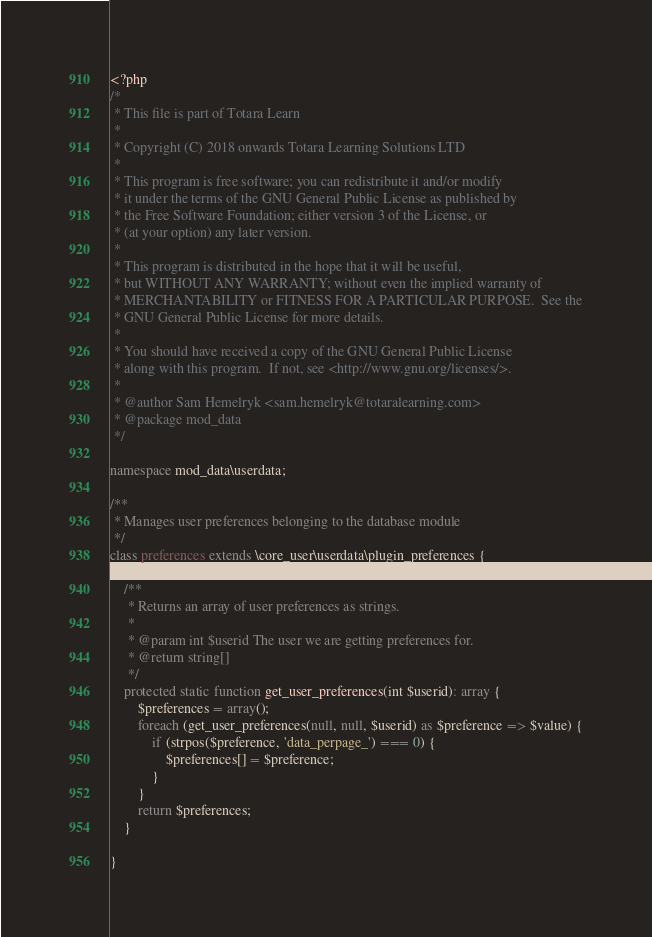Convert code to text. <code><loc_0><loc_0><loc_500><loc_500><_PHP_><?php
/*
 * This file is part of Totara Learn
 *
 * Copyright (C) 2018 onwards Totara Learning Solutions LTD
 *
 * This program is free software; you can redistribute it and/or modify
 * it under the terms of the GNU General Public License as published by
 * the Free Software Foundation; either version 3 of the License, or
 * (at your option) any later version.
 *
 * This program is distributed in the hope that it will be useful,
 * but WITHOUT ANY WARRANTY; without even the implied warranty of
 * MERCHANTABILITY or FITNESS FOR A PARTICULAR PURPOSE.  See the
 * GNU General Public License for more details.
 *
 * You should have received a copy of the GNU General Public License
 * along with this program.  If not, see <http://www.gnu.org/licenses/>.
 *
 * @author Sam Hemelryk <sam.hemelryk@totaralearning.com>
 * @package mod_data
 */

namespace mod_data\userdata;

/**
 * Manages user preferences belonging to the database module
 */
class preferences extends \core_user\userdata\plugin_preferences {

    /**
     * Returns an array of user preferences as strings.
     *
     * @param int $userid The user we are getting preferences for.
     * @return string[]
     */
    protected static function get_user_preferences(int $userid): array {
        $preferences = array();
        foreach (get_user_preferences(null, null, $userid) as $preference => $value) {
            if (strpos($preference, 'data_perpage_') === 0) {
                $preferences[] = $preference;
            }
        }
        return $preferences;
    }

}
</code> 